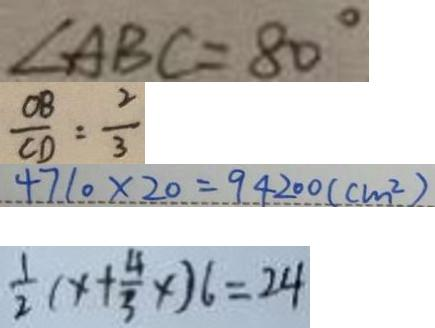<formula> <loc_0><loc_0><loc_500><loc_500>\angle A B C = 8 0 ^ { \circ } 
 \frac { O B } { C D } = \frac { 2 } { 3 } 
 4 7 1 0 \times 2 0 = 9 4 2 0 0 ( c m ^ { 2 } ) 
 \frac { 1 } { 2 } ( x + \frac { 4 } { 3 } x ) 6 = 2 4</formula> 